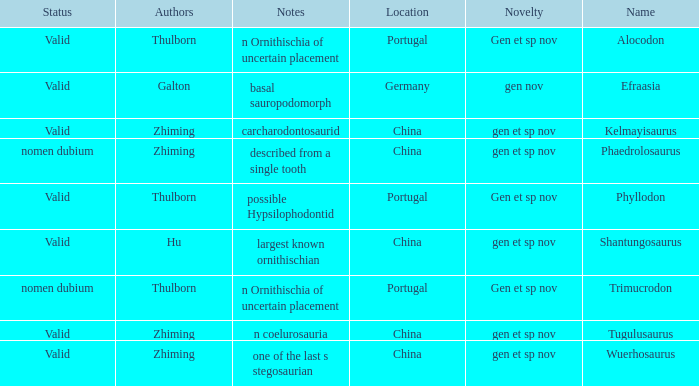Could you parse the entire table as a dict? {'header': ['Status', 'Authors', 'Notes', 'Location', 'Novelty', 'Name'], 'rows': [['Valid', 'Thulborn', 'n Ornithischia of uncertain placement', 'Portugal', 'Gen et sp nov', 'Alocodon'], ['Valid', 'Galton', 'basal sauropodomorph', 'Germany', 'gen nov', 'Efraasia'], ['Valid', 'Zhiming', 'carcharodontosaurid', 'China', 'gen et sp nov', 'Kelmayisaurus'], ['nomen dubium', 'Zhiming', 'described from a single tooth', 'China', 'gen et sp nov', 'Phaedrolosaurus'], ['Valid', 'Thulborn', 'possible Hypsilophodontid', 'Portugal', 'Gen et sp nov', 'Phyllodon'], ['Valid', 'Hu', 'largest known ornithischian', 'China', 'gen et sp nov', 'Shantungosaurus'], ['nomen dubium', 'Thulborn', 'n Ornithischia of uncertain placement', 'Portugal', 'Gen et sp nov', 'Trimucrodon'], ['Valid', 'Zhiming', 'n coelurosauria', 'China', 'gen et sp nov', 'Tugulusaurus'], ['Valid', 'Zhiming', 'one of the last s stegosaurian', 'China', 'gen et sp nov', 'Wuerhosaurus']]} What is the Name of the dinosaur, whose notes are, "n ornithischia of uncertain placement"? Alocodon, Trimucrodon. 